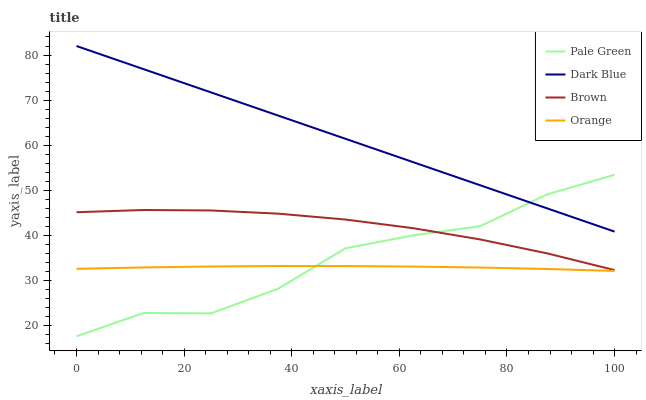Does Orange have the minimum area under the curve?
Answer yes or no. Yes. Does Dark Blue have the maximum area under the curve?
Answer yes or no. Yes. Does Pale Green have the minimum area under the curve?
Answer yes or no. No. Does Pale Green have the maximum area under the curve?
Answer yes or no. No. Is Dark Blue the smoothest?
Answer yes or no. Yes. Is Pale Green the roughest?
Answer yes or no. Yes. Is Pale Green the smoothest?
Answer yes or no. No. Is Dark Blue the roughest?
Answer yes or no. No. Does Pale Green have the lowest value?
Answer yes or no. Yes. Does Dark Blue have the lowest value?
Answer yes or no. No. Does Dark Blue have the highest value?
Answer yes or no. Yes. Does Pale Green have the highest value?
Answer yes or no. No. Is Orange less than Dark Blue?
Answer yes or no. Yes. Is Dark Blue greater than Orange?
Answer yes or no. Yes. Does Brown intersect Pale Green?
Answer yes or no. Yes. Is Brown less than Pale Green?
Answer yes or no. No. Is Brown greater than Pale Green?
Answer yes or no. No. Does Orange intersect Dark Blue?
Answer yes or no. No. 